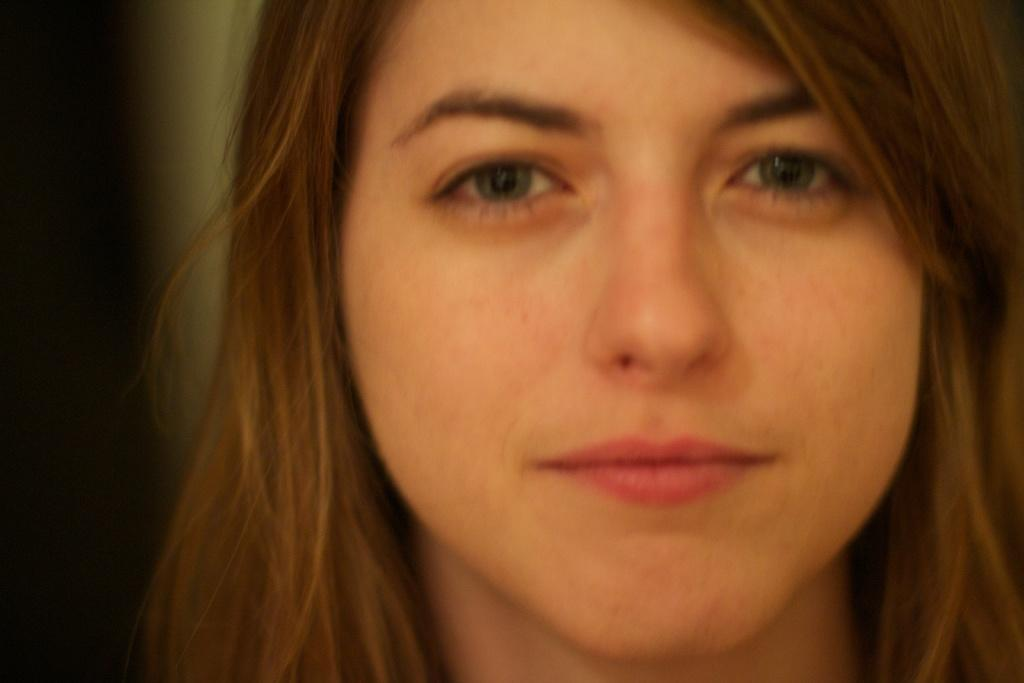What is the main subject of the image? The main subject of the image is women. Can you describe the location of the women in the image? The women are in the center of the image. What type of prose is being read by the women in the image? There is no indication in the image that the women are reading any prose, so it cannot be determined from the picture. 